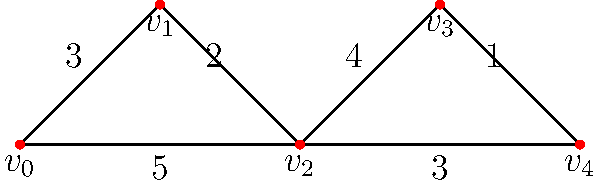In a video game, you need to navigate through a dungeon represented by the graph above. Each edge represents a path between two rooms, and the numbers on the edges represent the time (in minutes) it takes to traverse that path. What's the shortest time needed to go from room $v_0$ to room $v_4$? To find the shortest path, we'll use Dijkstra's algorithm:

1) Initialize:
   - Distance to $v_0$ = 0
   - Distance to all other vertices = $\infty$

2) Visit $v_0$:
   - Update $v_1$: 0 + 3 = 3
   - Update $v_2$: 0 + 5 = 5

3) Visit $v_1$ (closest unvisited vertex):
   - Update $v_2$: min(5, 3 + 2) = 5

4) Visit $v_2$:
   - Update $v_3$: 5 + 4 = 9
   - Update $v_4$: 5 + 3 = 8

5) Visit $v_4$ (closer than $v_3$):
   - No updates needed

6) Visit $v_3$:
   - Update $v_4$: min(8, 9 + 1) = 8

The shortest path is $v_0 \rightarrow v_2 \rightarrow v_4$, with a total time of 8 minutes.
Answer: 8 minutes 